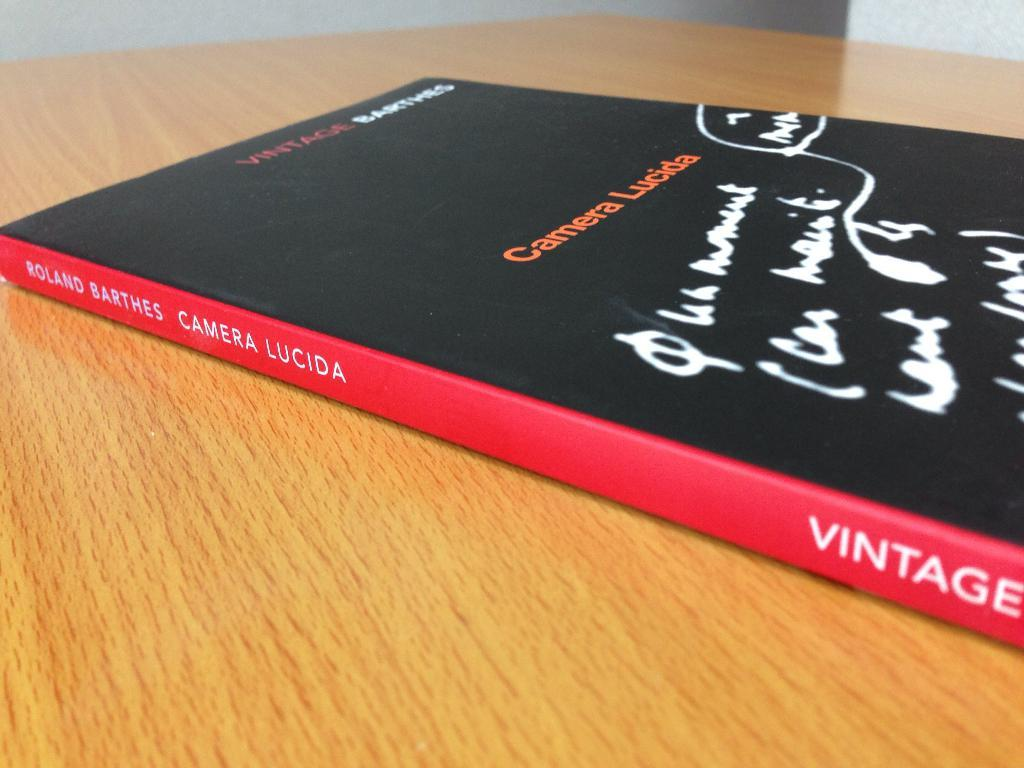<image>
Write a terse but informative summary of the picture. A book titled Camera Lucida by Roland Barthes on a wooden table top. 